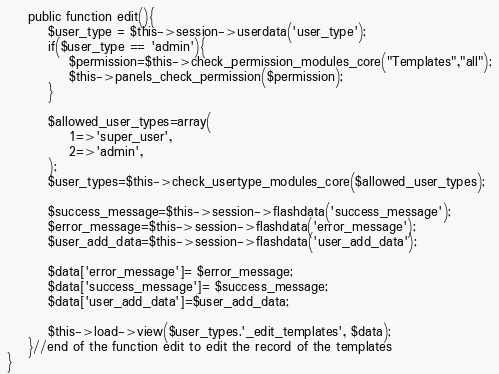<code> <loc_0><loc_0><loc_500><loc_500><_PHP_>	public function edit(){
		$user_type = $this->session->userdata('user_type');
		if($user_type == 'admin'){
			$permission=$this->check_permission_modules_core("Templates","all");
			$this->panels_check_permission($permission);
		}	
		
		$allowed_user_types=array(
			1=>'super_user',
			2=>'admin',
		);
		$user_types=$this->check_usertype_modules_core($allowed_user_types);
		
		$success_message=$this->session->flashdata('success_message');
		$error_message=$this->session->flashdata('error_message');
		$user_add_data=$this->session->flashdata('user_add_data');
		
    	$data['error_message']= $error_message;
		$data['success_message']= $success_message;
		$data['user_add_data']=$user_add_data;
		
		$this->load->view($user_types.'_edit_templates', $data);
	}//end of the function edit to edit the record of the templates
}</code> 